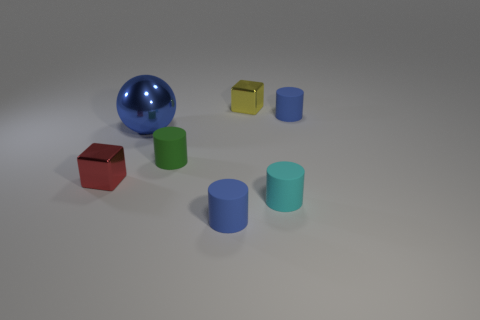There is another thing that is the same shape as the red thing; what material is it?
Your answer should be compact. Metal. Do the blue thing that is in front of the large blue metallic ball and the tiny red cube have the same material?
Keep it short and to the point. No. Is the number of metallic blocks that are in front of the big blue metallic sphere greater than the number of green cylinders that are on the right side of the tiny cyan matte object?
Offer a terse response. Yes. The yellow metallic block has what size?
Provide a short and direct response. Small. What is the shape of the small green thing that is made of the same material as the tiny cyan cylinder?
Your answer should be compact. Cylinder. There is a tiny blue rubber object that is behind the small red shiny thing; is it the same shape as the tiny cyan object?
Give a very brief answer. Yes. What number of objects are either tiny yellow objects or small cylinders?
Offer a terse response. 5. What is the tiny thing that is both on the left side of the tiny cyan object and behind the green cylinder made of?
Offer a terse response. Metal. Do the cyan object and the green cylinder have the same size?
Make the answer very short. Yes. What is the size of the cyan rubber cylinder that is in front of the small blue cylinder behind the small red metallic cube?
Offer a terse response. Small. 